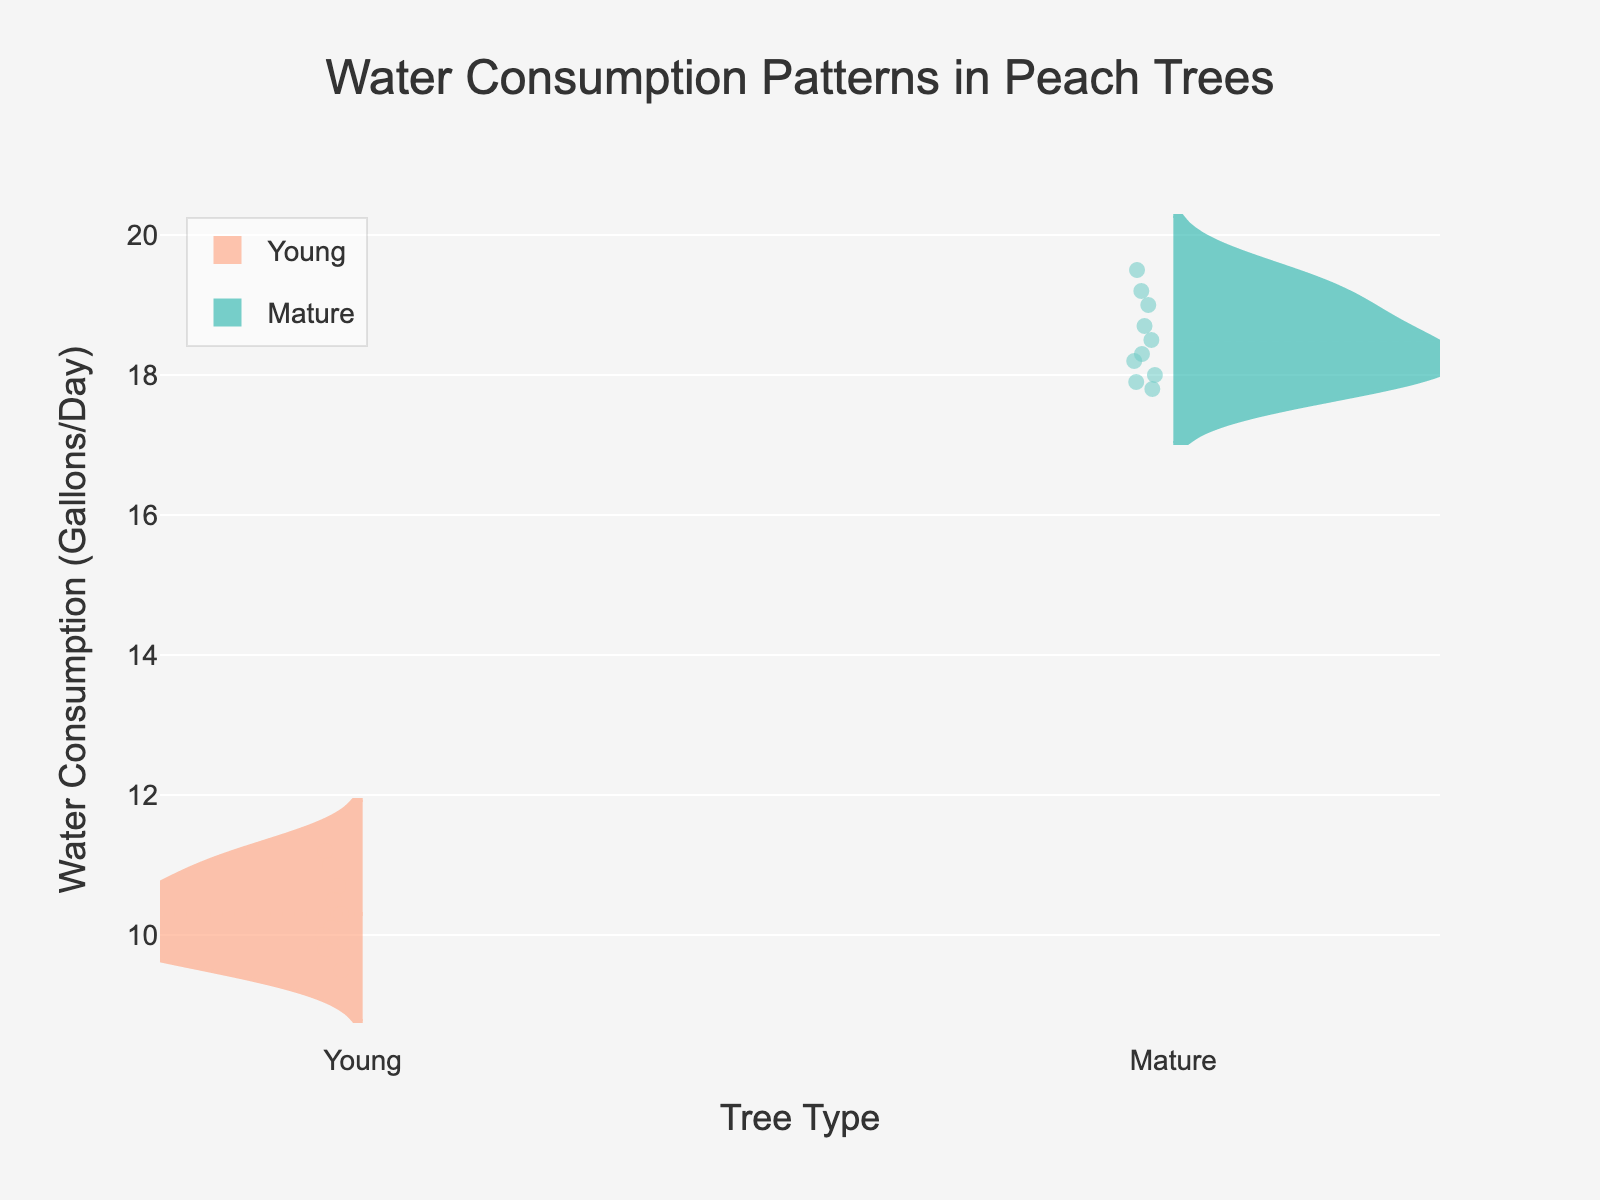What's the title of the plot? The title is positioned at the top of the plot and it's the first text one usually sees
Answer: Water Consumption Patterns in Peach Trees What are the units for water consumption on the y-axis? The y-axis title indicates the units for water consumption in the plot
Answer: Gallons/Day Which type of trees have higher average water consumption, young or mature? By observing the density and spread of the violin plot, one can determine which group generally consumes more water
Answer: Mature trees What is the range of water consumption for mature peach trees? The range can be determined by looking at the extremes of the mature violin plot
Answer: 17.8 to 19.5 Gallons/Day How many data points are displayed in each tree type? The plot displays all data points within the violin plot for each group, helping to count them
Answer: 10 for both young and mature trees What does the line in the middle of the violin plots represent? The line in the middle of the violin plot shows the mean value
Answer: Mean value How does the variability in water consumption compare between young and mature trees? The spread and density of the violin plot indicate variation, with a more spread suggesting higher variability
Answer: Young trees have higher variability What's the mean water consumption for young peach trees? The position of the mean line within the young trees' plot indicates this value
Answer: Approximately 10.2 Gallons/Day Is there any overlap in water consumption values between the two tree types? By examining the density plots, one can determine if there's any overlap in the water consumption values
Answer: No Which tree type has data points that are more densely packed? Comparing the density of the two violin plots will reveal which group's data points are closer together
Answer: Mature trees 